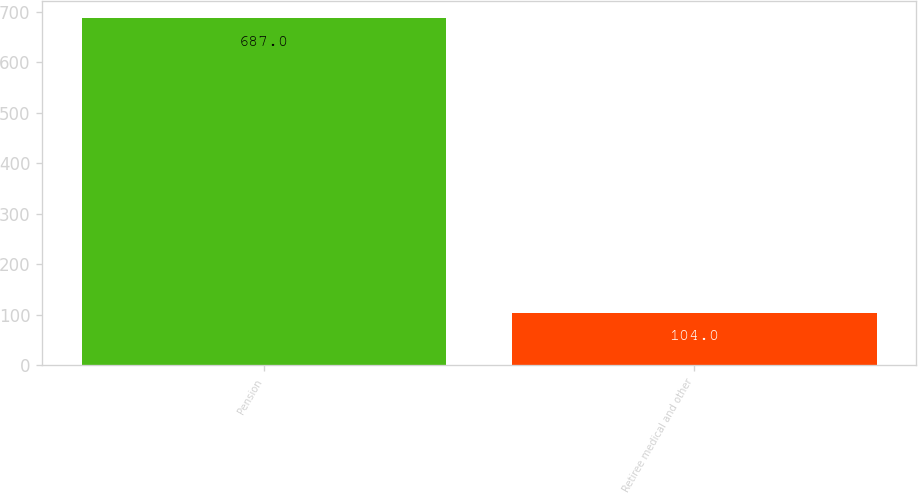<chart> <loc_0><loc_0><loc_500><loc_500><bar_chart><fcel>Pension<fcel>Retiree medical and other<nl><fcel>687<fcel>104<nl></chart> 